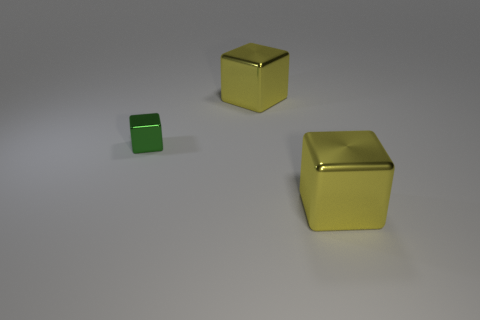Add 3 small purple metal cubes. How many objects exist? 6 Subtract all gray cubes. Subtract all cyan cylinders. How many cubes are left? 3 Subtract 1 yellow blocks. How many objects are left? 2 Subtract all small green shiny objects. Subtract all big yellow metallic cubes. How many objects are left? 0 Add 3 green things. How many green things are left? 4 Add 1 tiny yellow things. How many tiny yellow things exist? 1 